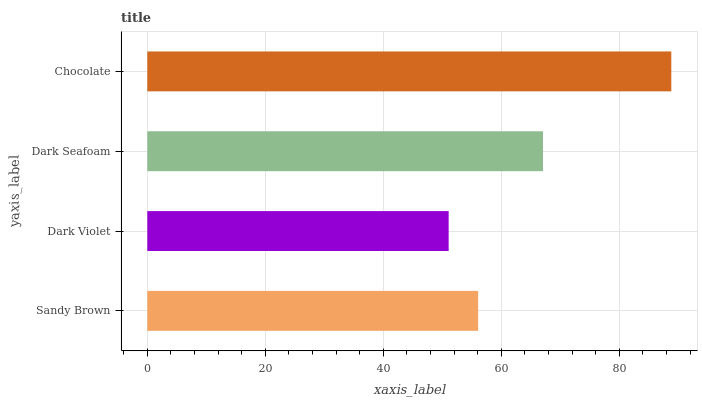Is Dark Violet the minimum?
Answer yes or no. Yes. Is Chocolate the maximum?
Answer yes or no. Yes. Is Dark Seafoam the minimum?
Answer yes or no. No. Is Dark Seafoam the maximum?
Answer yes or no. No. Is Dark Seafoam greater than Dark Violet?
Answer yes or no. Yes. Is Dark Violet less than Dark Seafoam?
Answer yes or no. Yes. Is Dark Violet greater than Dark Seafoam?
Answer yes or no. No. Is Dark Seafoam less than Dark Violet?
Answer yes or no. No. Is Dark Seafoam the high median?
Answer yes or no. Yes. Is Sandy Brown the low median?
Answer yes or no. Yes. Is Chocolate the high median?
Answer yes or no. No. Is Chocolate the low median?
Answer yes or no. No. 